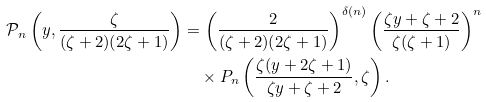<formula> <loc_0><loc_0><loc_500><loc_500>\mathcal { P } _ { n } \left ( y , \frac { \zeta } { ( \zeta + 2 ) ( 2 \zeta + 1 ) } \right ) & = \left ( \frac { 2 } { ( \zeta + 2 ) ( 2 \zeta + 1 ) } \right ) ^ { \delta ( n ) } \left ( \frac { \zeta y + \zeta + 2 } { \zeta ( \zeta + 1 ) } \right ) ^ { n } \\ & \quad \times P _ { n } \left ( \frac { \zeta ( y + 2 \zeta + 1 ) } { \zeta y + \zeta + 2 } , \zeta \right ) .</formula> 